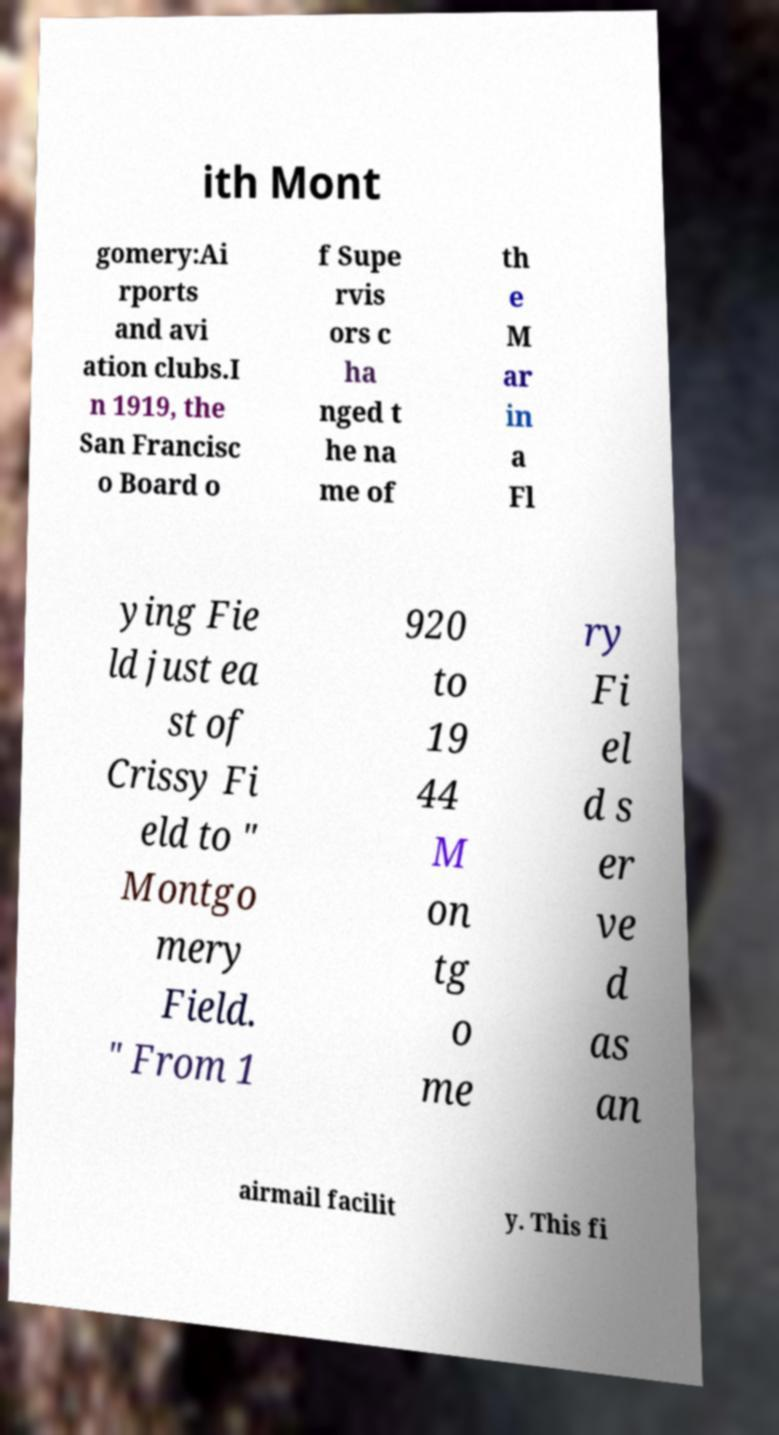Can you accurately transcribe the text from the provided image for me? ith Mont gomery:Ai rports and avi ation clubs.I n 1919, the San Francisc o Board o f Supe rvis ors c ha nged t he na me of th e M ar in a Fl ying Fie ld just ea st of Crissy Fi eld to " Montgo mery Field. " From 1 920 to 19 44 M on tg o me ry Fi el d s er ve d as an airmail facilit y. This fi 